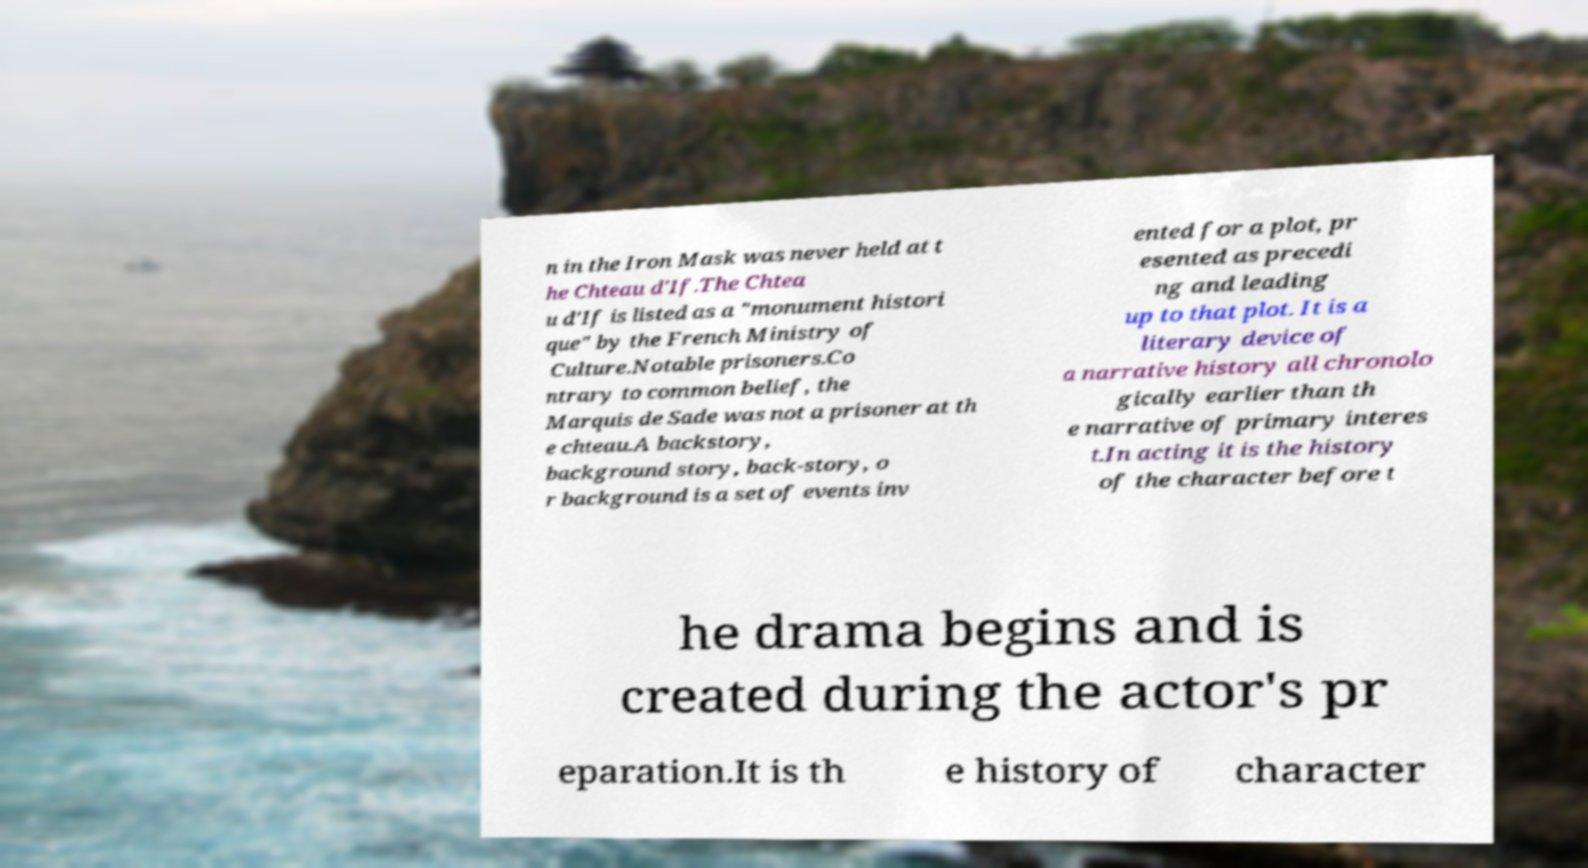Please read and relay the text visible in this image. What does it say? n in the Iron Mask was never held at t he Chteau d'If.The Chtea u d'If is listed as a "monument histori que" by the French Ministry of Culture.Notable prisoners.Co ntrary to common belief, the Marquis de Sade was not a prisoner at th e chteau.A backstory, background story, back-story, o r background is a set of events inv ented for a plot, pr esented as precedi ng and leading up to that plot. It is a literary device of a narrative history all chronolo gically earlier than th e narrative of primary interes t.In acting it is the history of the character before t he drama begins and is created during the actor's pr eparation.It is th e history of character 